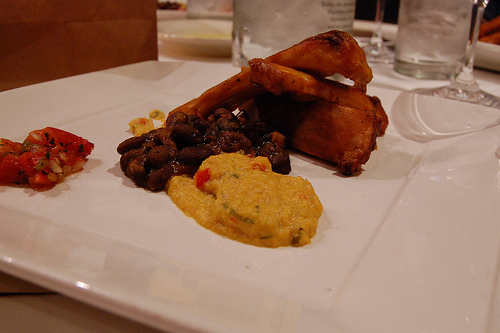<image>
Is there a curry behind the beans? No. The curry is not behind the beans. From this viewpoint, the curry appears to be positioned elsewhere in the scene. 